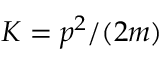<formula> <loc_0><loc_0><loc_500><loc_500>K = p ^ { 2 } / ( 2 m )</formula> 